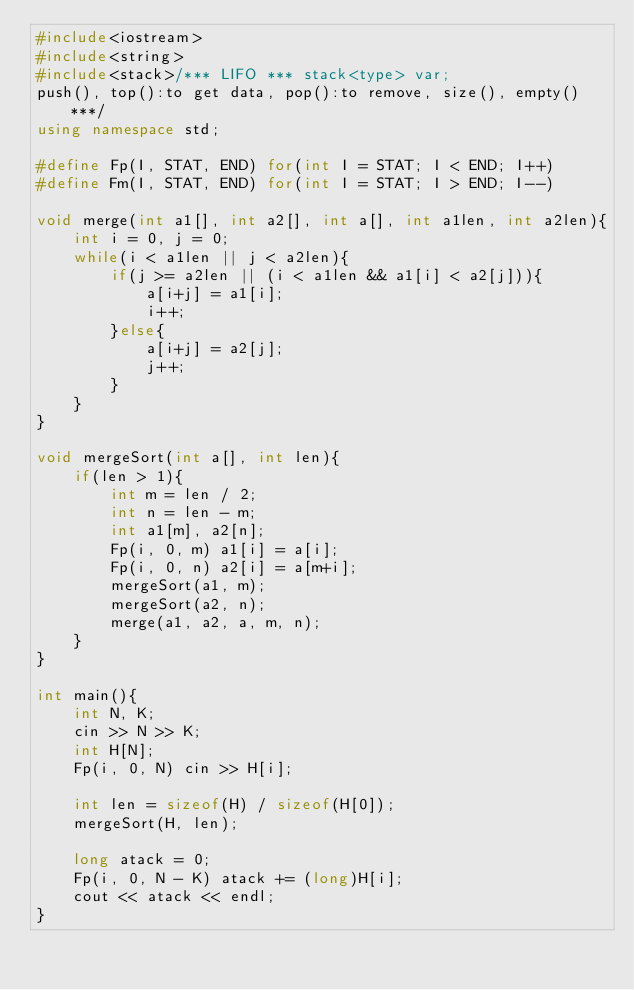<code> <loc_0><loc_0><loc_500><loc_500><_C++_>#include<iostream>
#include<string>
#include<stack>/*** LIFO *** stack<type> var;
push(), top():to get data, pop():to remove, size(), empty() ***/
using namespace std;

#define Fp(I, STAT, END) for(int I = STAT; I < END; I++)
#define Fm(I, STAT, END) for(int I = STAT; I > END; I--)

void merge(int a1[], int a2[], int a[], int a1len, int a2len){
    int i = 0, j = 0;
    while(i < a1len || j < a2len){
        if(j >= a2len || (i < a1len && a1[i] < a2[j])){
	        a[i+j] = a1[i];
	        i++;
        }else{
	        a[i+j] = a2[j];
	        j++;
        }
    }
}

void mergeSort(int a[], int len){
    if(len > 1){
        int m = len / 2;
        int n = len - m;
        int a1[m], a2[n];
        Fp(i, 0, m) a1[i] = a[i];
        Fp(i, 0, n) a2[i] = a[m+i];
        mergeSort(a1, m);
        mergeSort(a2, n);
        merge(a1, a2, a, m, n);
    }
}

int main(){
    int N, K;
    cin >> N >> K;
    int H[N];
    Fp(i, 0, N) cin >> H[i];

    int len = sizeof(H) / sizeof(H[0]);
    mergeSort(H, len);
    
    long atack = 0;
    Fp(i, 0, N - K) atack += (long)H[i];
    cout << atack << endl;
}
</code> 